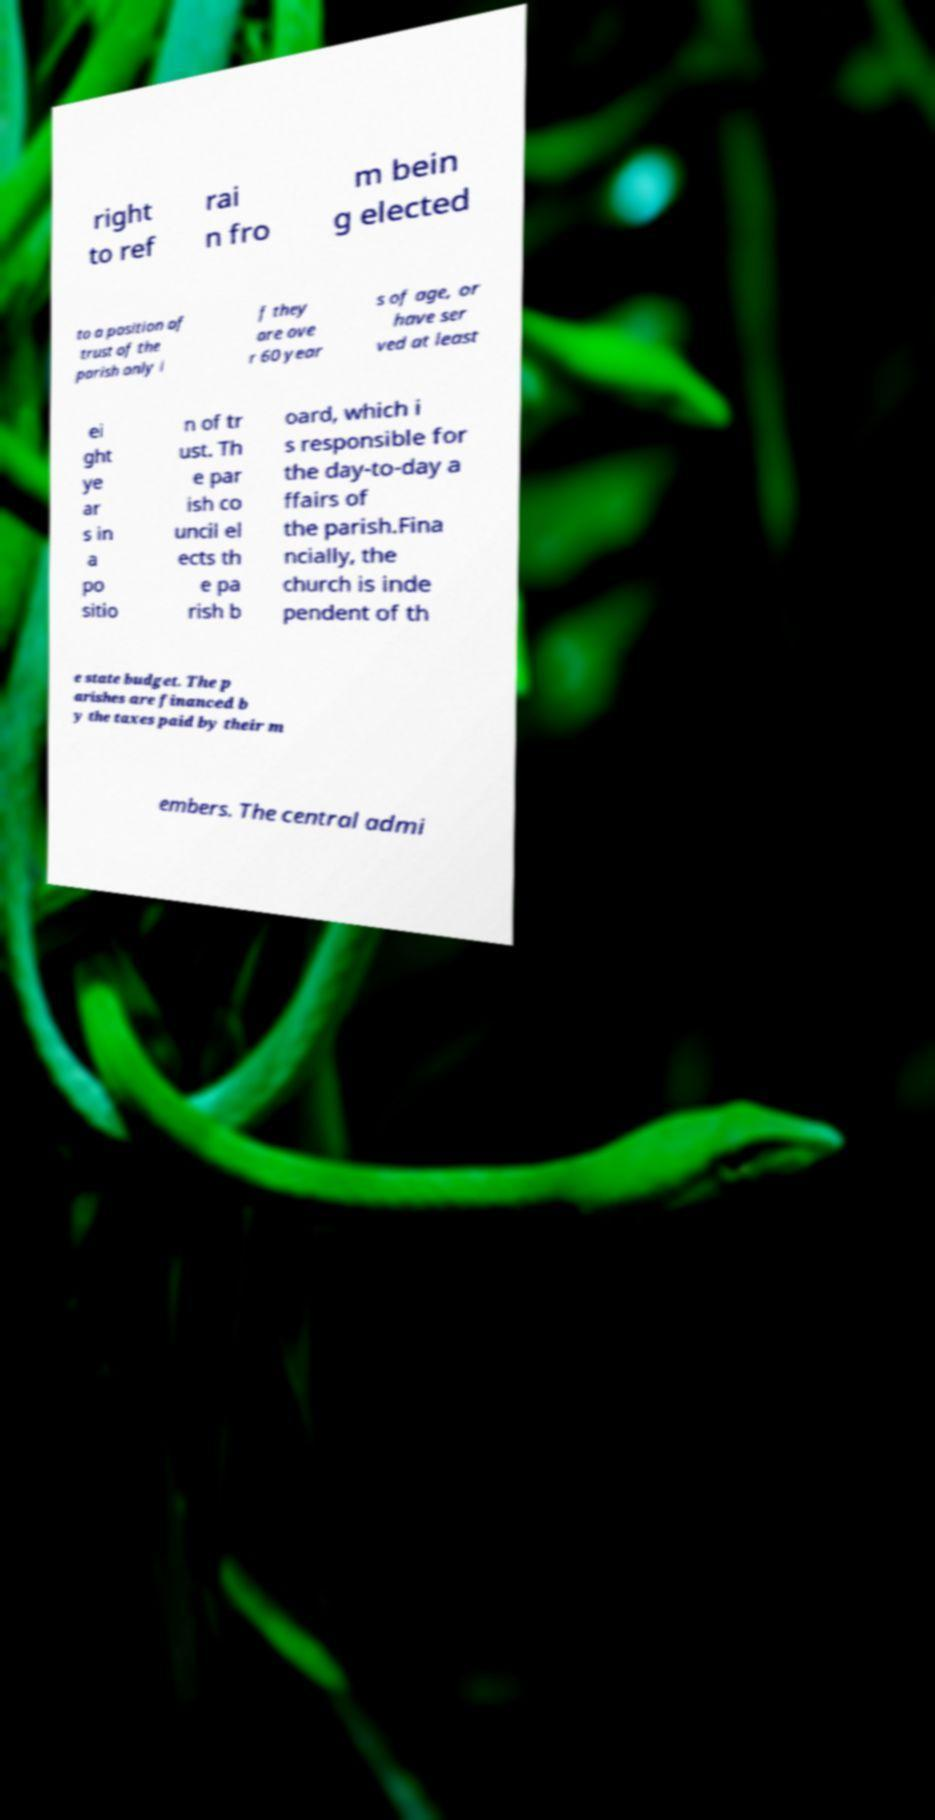There's text embedded in this image that I need extracted. Can you transcribe it verbatim? right to ref rai n fro m bein g elected to a position of trust of the parish only i f they are ove r 60 year s of age, or have ser ved at least ei ght ye ar s in a po sitio n of tr ust. Th e par ish co uncil el ects th e pa rish b oard, which i s responsible for the day-to-day a ffairs of the parish.Fina ncially, the church is inde pendent of th e state budget. The p arishes are financed b y the taxes paid by their m embers. The central admi 